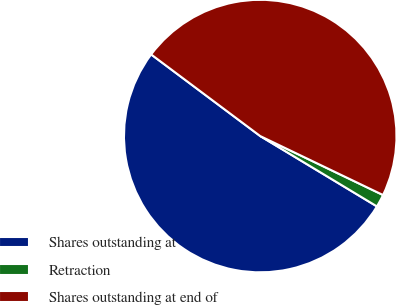Convert chart to OTSL. <chart><loc_0><loc_0><loc_500><loc_500><pie_chart><fcel>Shares outstanding at<fcel>Retraction<fcel>Shares outstanding at end of<nl><fcel>51.59%<fcel>1.51%<fcel>46.9%<nl></chart> 